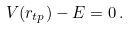Convert formula to latex. <formula><loc_0><loc_0><loc_500><loc_500>V ( r _ { t p } ) - E = 0 \, .</formula> 